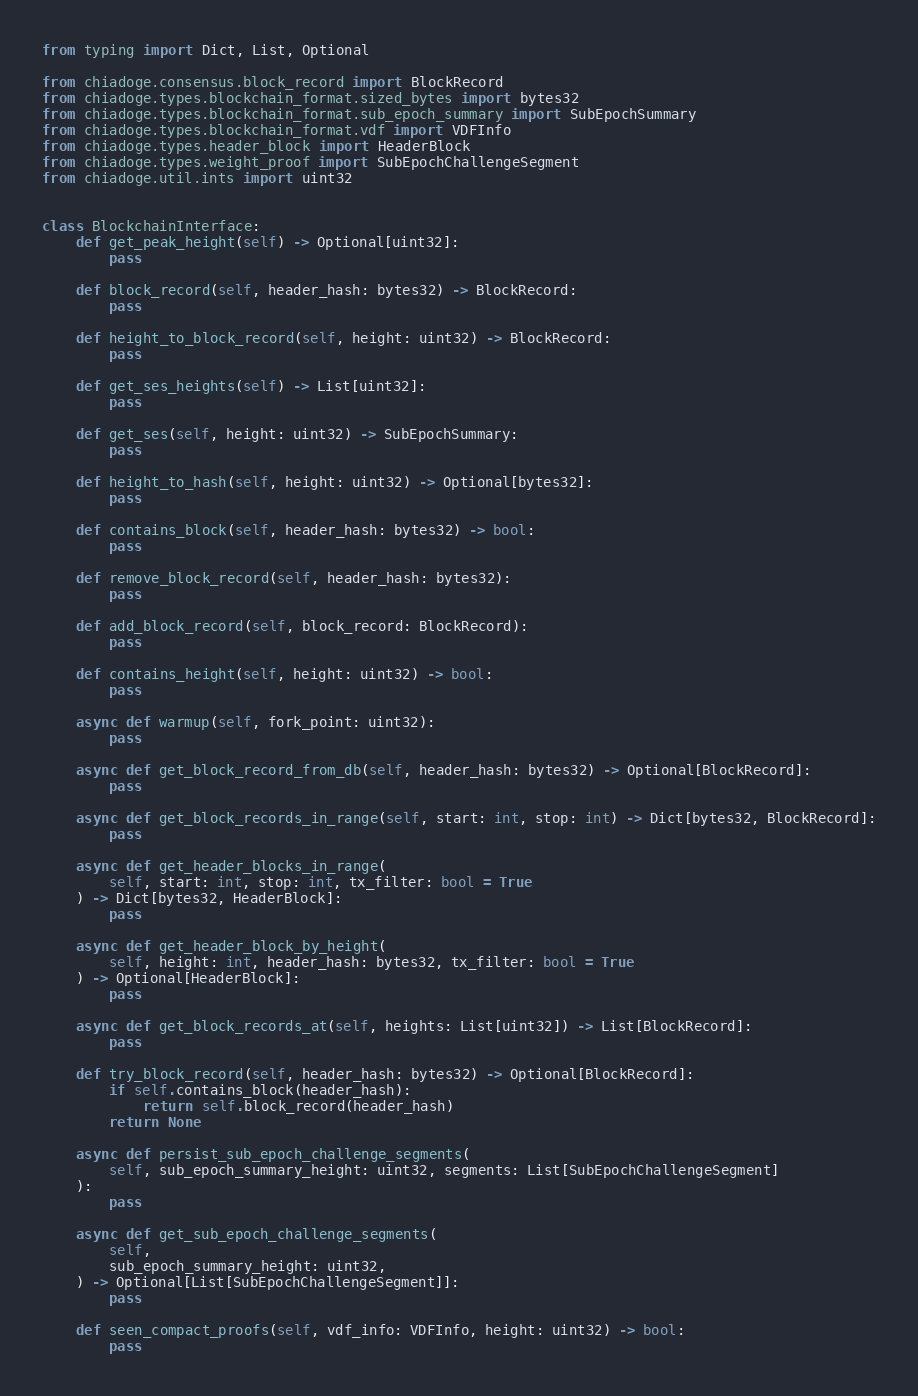Convert code to text. <code><loc_0><loc_0><loc_500><loc_500><_Python_>from typing import Dict, List, Optional

from chiadoge.consensus.block_record import BlockRecord
from chiadoge.types.blockchain_format.sized_bytes import bytes32
from chiadoge.types.blockchain_format.sub_epoch_summary import SubEpochSummary
from chiadoge.types.blockchain_format.vdf import VDFInfo
from chiadoge.types.header_block import HeaderBlock
from chiadoge.types.weight_proof import SubEpochChallengeSegment
from chiadoge.util.ints import uint32


class BlockchainInterface:
    def get_peak_height(self) -> Optional[uint32]:
        pass

    def block_record(self, header_hash: bytes32) -> BlockRecord:
        pass

    def height_to_block_record(self, height: uint32) -> BlockRecord:
        pass

    def get_ses_heights(self) -> List[uint32]:
        pass

    def get_ses(self, height: uint32) -> SubEpochSummary:
        pass

    def height_to_hash(self, height: uint32) -> Optional[bytes32]:
        pass

    def contains_block(self, header_hash: bytes32) -> bool:
        pass

    def remove_block_record(self, header_hash: bytes32):
        pass

    def add_block_record(self, block_record: BlockRecord):
        pass

    def contains_height(self, height: uint32) -> bool:
        pass

    async def warmup(self, fork_point: uint32):
        pass

    async def get_block_record_from_db(self, header_hash: bytes32) -> Optional[BlockRecord]:
        pass

    async def get_block_records_in_range(self, start: int, stop: int) -> Dict[bytes32, BlockRecord]:
        pass

    async def get_header_blocks_in_range(
        self, start: int, stop: int, tx_filter: bool = True
    ) -> Dict[bytes32, HeaderBlock]:
        pass

    async def get_header_block_by_height(
        self, height: int, header_hash: bytes32, tx_filter: bool = True
    ) -> Optional[HeaderBlock]:
        pass

    async def get_block_records_at(self, heights: List[uint32]) -> List[BlockRecord]:
        pass

    def try_block_record(self, header_hash: bytes32) -> Optional[BlockRecord]:
        if self.contains_block(header_hash):
            return self.block_record(header_hash)
        return None

    async def persist_sub_epoch_challenge_segments(
        self, sub_epoch_summary_height: uint32, segments: List[SubEpochChallengeSegment]
    ):
        pass

    async def get_sub_epoch_challenge_segments(
        self,
        sub_epoch_summary_height: uint32,
    ) -> Optional[List[SubEpochChallengeSegment]]:
        pass

    def seen_compact_proofs(self, vdf_info: VDFInfo, height: uint32) -> bool:
        pass
</code> 